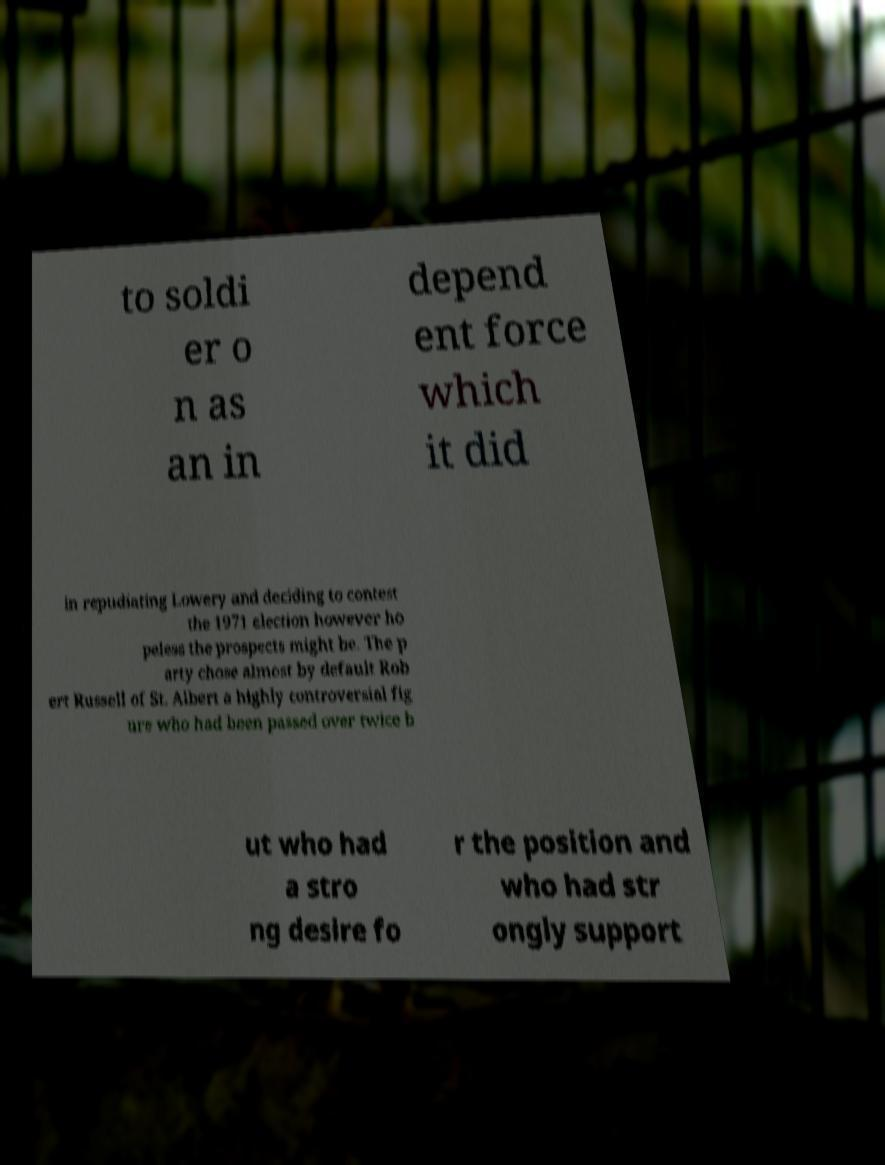Could you extract and type out the text from this image? to soldi er o n as an in depend ent force which it did in repudiating Lowery and deciding to contest the 1971 election however ho peless the prospects might be. The p arty chose almost by default Rob ert Russell of St. Albert a highly controversial fig ure who had been passed over twice b ut who had a stro ng desire fo r the position and who had str ongly support 